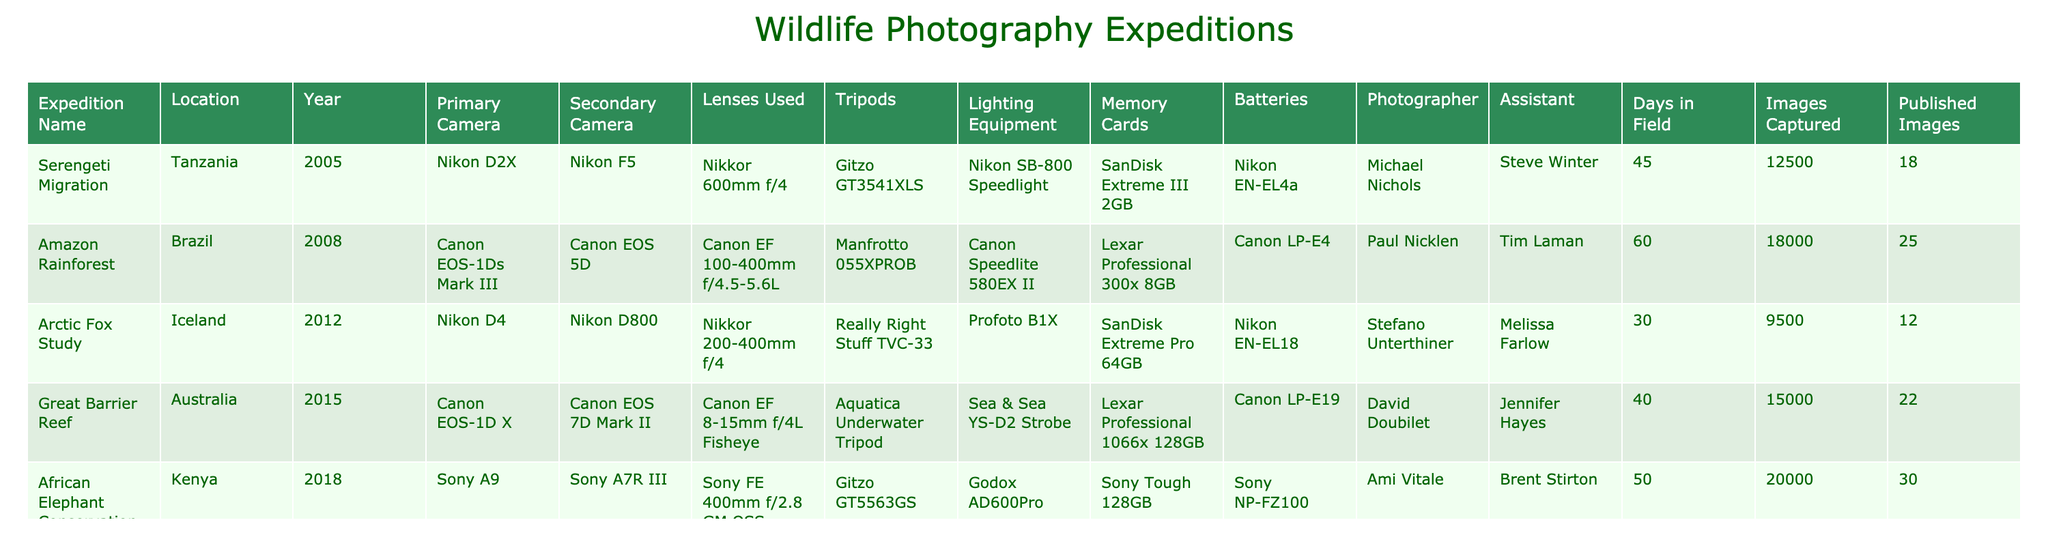What was the primary camera used in the African Elephant Conservation expedition? The African Elephant Conservation expedition lists the primary camera as "Sony A9."
Answer: Sony A9 How many images were captured during the Amazon Rainforest expedition? The table indicates that the Amazon Rainforest expedition resulted in the capture of 18,000 images.
Answer: 18000 What is the total number of published images across all expeditions? By adding the published images: 18 + 25 + 12 + 22 + 30 = 107.
Answer: 107 Which expedition had the highest number of days in the field? Comparing the "Days in Field" values: 45, 60, 30, 40, 50; the highest is 60 days for the Amazon Rainforest expedition.
Answer: Amazon Rainforest Did the Arctic Fox Study use a Canon camera? The Arctic Fox Study used Nikon cameras (D4 and D800), which means no Canon camera was involved.
Answer: No Which expedition had the most images captured per day? Calculate images per day for each expedition: Serengeti (12500/45 = 277.8), Amazon (18000/60 = 300), Arctic Fox (9500/30 = 316.7), Great Barrier Reef (15000/40 = 375), African Elephant (20000/50 = 400). The African Elephant Conservation led with the highest at 400 images per day.
Answer: African Elephant Conservation Which lens was used in both the Amazon Rainforest and Great Barrier Reef expeditions? The Amazon expedition used Canon EF 100-400mm f/4.5-5.6L and the Great Barrier Reef used Canon EF 8-15mm f/4L Fisheye. No lens was shared.
Answer: None What type of lighting equipment was used in the Arctic Fox Study? The Arctic Fox Study had "Profoto B1X" listed as the lighting equipment.
Answer: Profoto B1X Did the photographer for the Great Barrier Reef expedition also have an assistant? The Great Barrier Reef expedition lists "Jennifer Hayes" as the assistant for David Doubilet, affirming he had support.
Answer: Yes What is the average number of days spent in the field across all expeditions? Summing days gives 45 + 60 + 30 + 40 + 50 = 225. Dividing by 5 expeditions results in an average of 45 days.
Answer: 45 Which location hosted the least number of published images? The published images for each location are 18, 25, 12, 22, and 30; the Arctic Fox Study had the least with 12 published images.
Answer: Arctic Fox Study 